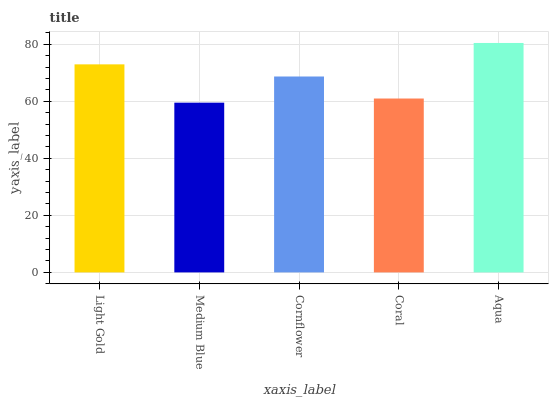Is Cornflower the minimum?
Answer yes or no. No. Is Cornflower the maximum?
Answer yes or no. No. Is Cornflower greater than Medium Blue?
Answer yes or no. Yes. Is Medium Blue less than Cornflower?
Answer yes or no. Yes. Is Medium Blue greater than Cornflower?
Answer yes or no. No. Is Cornflower less than Medium Blue?
Answer yes or no. No. Is Cornflower the high median?
Answer yes or no. Yes. Is Cornflower the low median?
Answer yes or no. Yes. Is Light Gold the high median?
Answer yes or no. No. Is Medium Blue the low median?
Answer yes or no. No. 